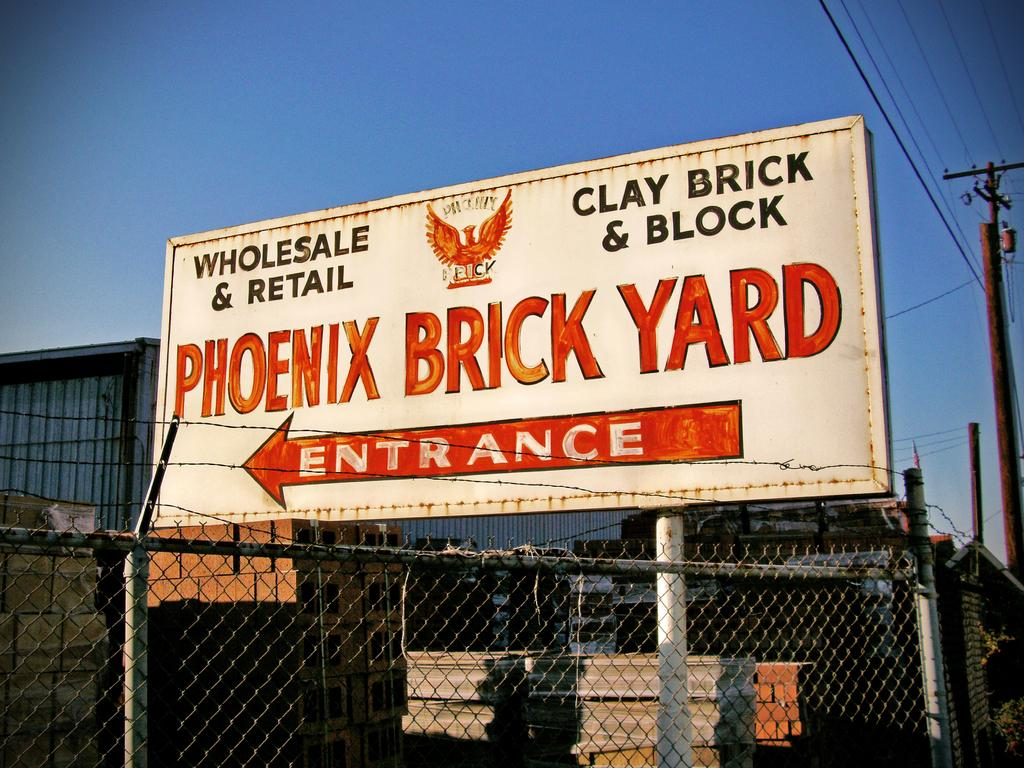<image>
Present a compact description of the photo's key features. A large billboard is pointing the way to the entrance of the Phoenix Brick Yard. 